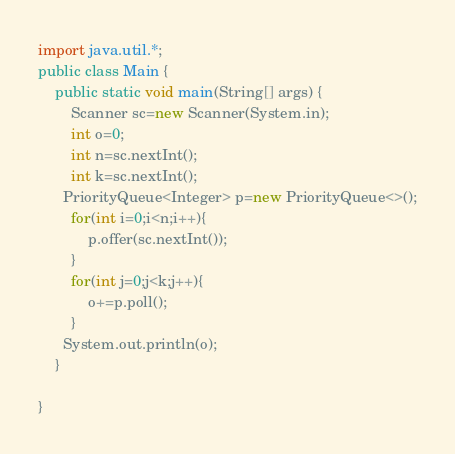<code> <loc_0><loc_0><loc_500><loc_500><_Java_>import java.util.*;
public class Main { 
    public static void main(String[] args) {
        Scanner sc=new Scanner(System.in);
        int o=0;
        int n=sc.nextInt();
        int k=sc.nextInt();
      PriorityQueue<Integer> p=new PriorityQueue<>();
      	for(int i=0;i<n;i++){
    		p.offer(sc.nextInt());
		}
        for(int j=0;j<k;j++){
          	o+=p.poll();
    	}
      System.out.println(o);
    }
    
}</code> 